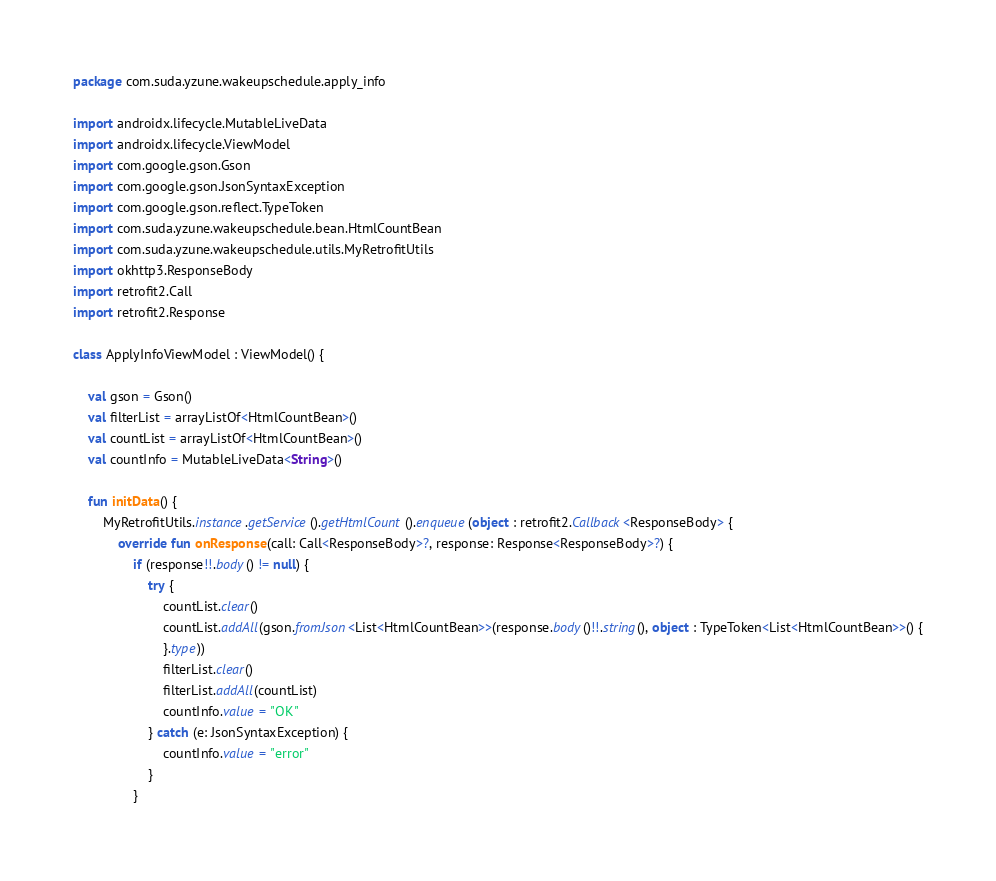<code> <loc_0><loc_0><loc_500><loc_500><_Kotlin_>package com.suda.yzune.wakeupschedule.apply_info

import androidx.lifecycle.MutableLiveData
import androidx.lifecycle.ViewModel
import com.google.gson.Gson
import com.google.gson.JsonSyntaxException
import com.google.gson.reflect.TypeToken
import com.suda.yzune.wakeupschedule.bean.HtmlCountBean
import com.suda.yzune.wakeupschedule.utils.MyRetrofitUtils
import okhttp3.ResponseBody
import retrofit2.Call
import retrofit2.Response

class ApplyInfoViewModel : ViewModel() {

    val gson = Gson()
    val filterList = arrayListOf<HtmlCountBean>()
    val countList = arrayListOf<HtmlCountBean>()
    val countInfo = MutableLiveData<String>()

    fun initData() {
        MyRetrofitUtils.instance.getService().getHtmlCount().enqueue(object : retrofit2.Callback<ResponseBody> {
            override fun onResponse(call: Call<ResponseBody>?, response: Response<ResponseBody>?) {
                if (response!!.body() != null) {
                    try {
                        countList.clear()
                        countList.addAll(gson.fromJson<List<HtmlCountBean>>(response.body()!!.string(), object : TypeToken<List<HtmlCountBean>>() {
                        }.type))
                        filterList.clear()
                        filterList.addAll(countList)
                        countInfo.value = "OK"
                    } catch (e: JsonSyntaxException) {
                        countInfo.value = "error"
                    }
                }</code> 